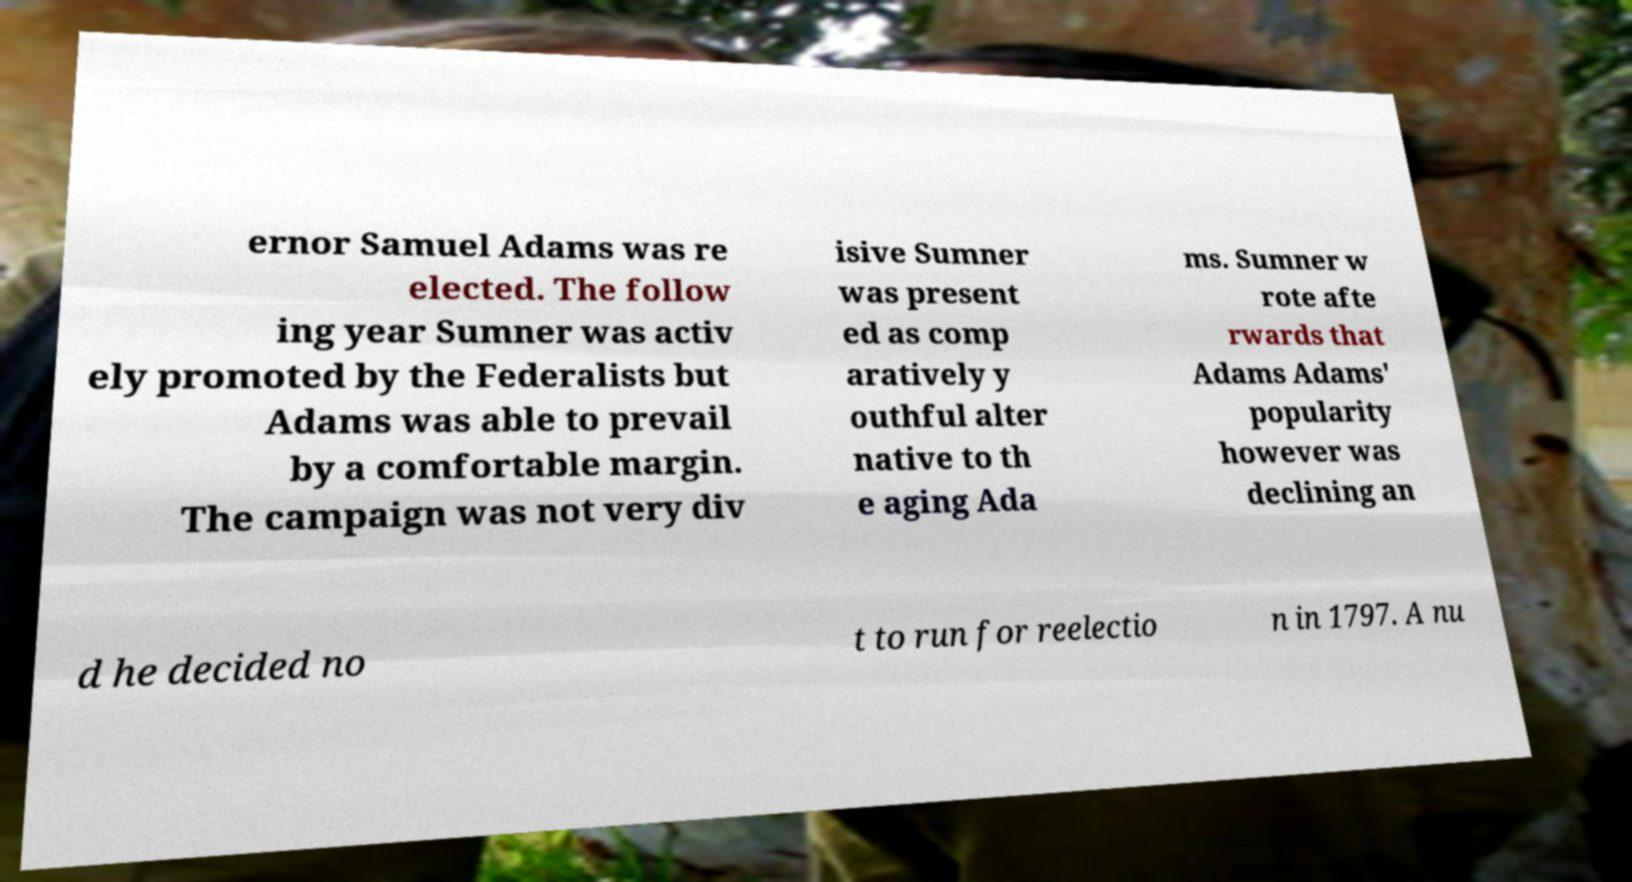Can you read and provide the text displayed in the image?This photo seems to have some interesting text. Can you extract and type it out for me? ernor Samuel Adams was re elected. The follow ing year Sumner was activ ely promoted by the Federalists but Adams was able to prevail by a comfortable margin. The campaign was not very div isive Sumner was present ed as comp aratively y outhful alter native to th e aging Ada ms. Sumner w rote afte rwards that Adams Adams' popularity however was declining an d he decided no t to run for reelectio n in 1797. A nu 